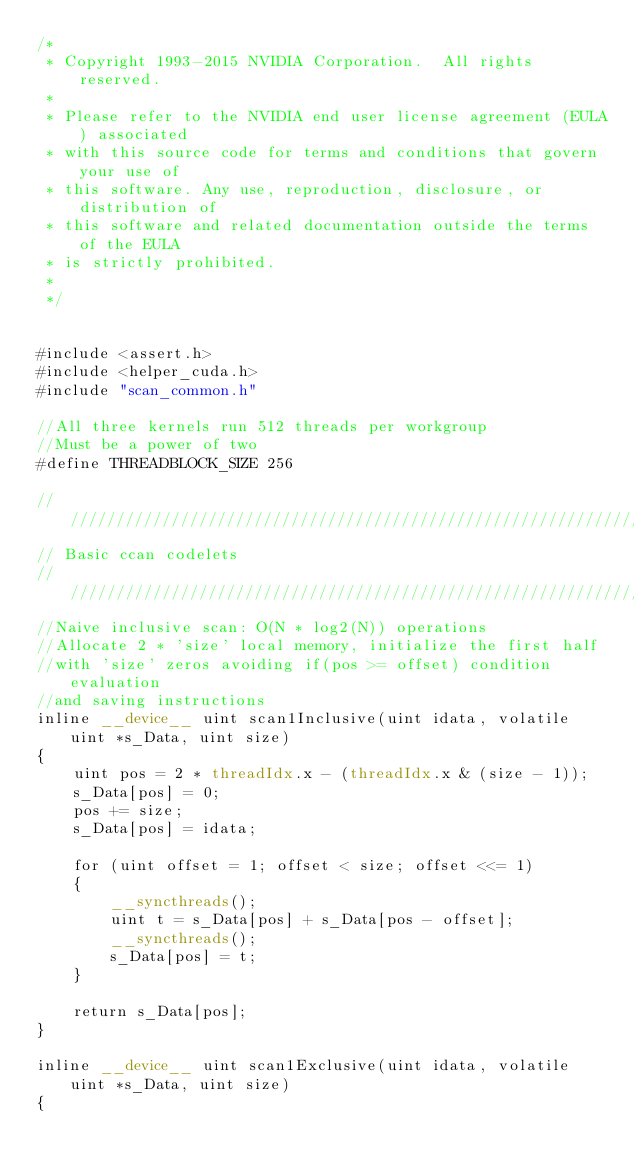<code> <loc_0><loc_0><loc_500><loc_500><_Cuda_>/*
 * Copyright 1993-2015 NVIDIA Corporation.  All rights reserved.
 *
 * Please refer to the NVIDIA end user license agreement (EULA) associated
 * with this source code for terms and conditions that govern your use of
 * this software. Any use, reproduction, disclosure, or distribution of
 * this software and related documentation outside the terms of the EULA
 * is strictly prohibited.
 *
 */


#include <assert.h>
#include <helper_cuda.h>
#include "scan_common.h"

//All three kernels run 512 threads per workgroup
//Must be a power of two
#define THREADBLOCK_SIZE 256

////////////////////////////////////////////////////////////////////////////////
// Basic ccan codelets
////////////////////////////////////////////////////////////////////////////////
//Naive inclusive scan: O(N * log2(N)) operations
//Allocate 2 * 'size' local memory, initialize the first half
//with 'size' zeros avoiding if(pos >= offset) condition evaluation
//and saving instructions
inline __device__ uint scan1Inclusive(uint idata, volatile uint *s_Data, uint size)
{
    uint pos = 2 * threadIdx.x - (threadIdx.x & (size - 1));
    s_Data[pos] = 0;
    pos += size;
    s_Data[pos] = idata;

    for (uint offset = 1; offset < size; offset <<= 1)
    {
        __syncthreads();
        uint t = s_Data[pos] + s_Data[pos - offset];
        __syncthreads();
        s_Data[pos] = t;
    }

    return s_Data[pos];
}

inline __device__ uint scan1Exclusive(uint idata, volatile uint *s_Data, uint size)
{</code> 